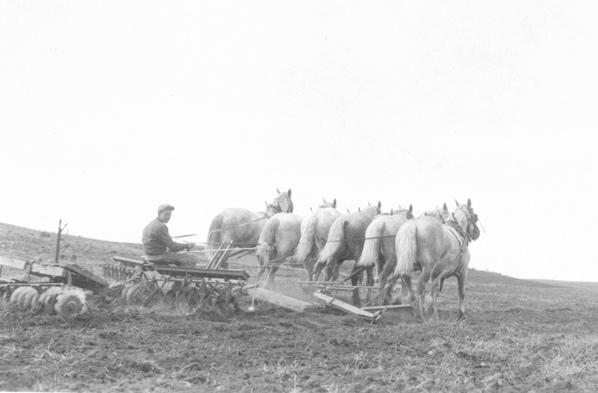Which animal is this?
Write a very short answer. Horse. What kind of animals are shown?
Quick response, please. Horses. How many horses are shown?
Keep it brief. 6. What color is the photo?
Give a very brief answer. Black and white. What animals are these?
Quick response, please. Horses. 